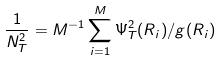<formula> <loc_0><loc_0><loc_500><loc_500>\frac { 1 } { N _ { T } ^ { 2 } } = M ^ { - 1 } \sum _ { i = 1 } ^ { M } \Psi _ { T } ^ { 2 } ( R _ { i } ) / g ( R _ { i } )</formula> 